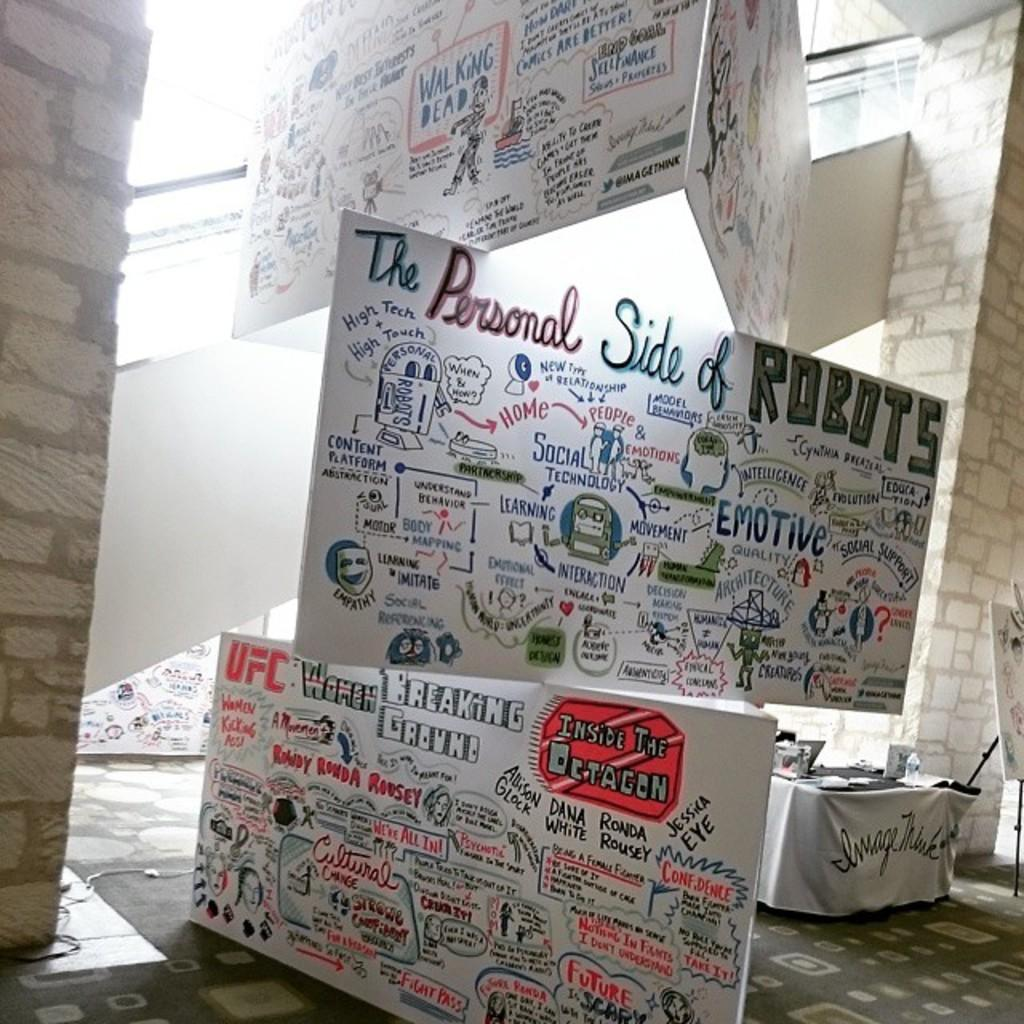What can be seen on the hoardings in the image? There are hoardings with text in the image. Where is the bottle located in the image? The bottle is present on a table in the background of the image. What else can be found on the table in the background of the image? There are other unspecified items on the table in the background of the image. How long does it take for the queen to walk across the ground in the image? There is no queen or ground present in the image, so it is not possible to answer that question. 